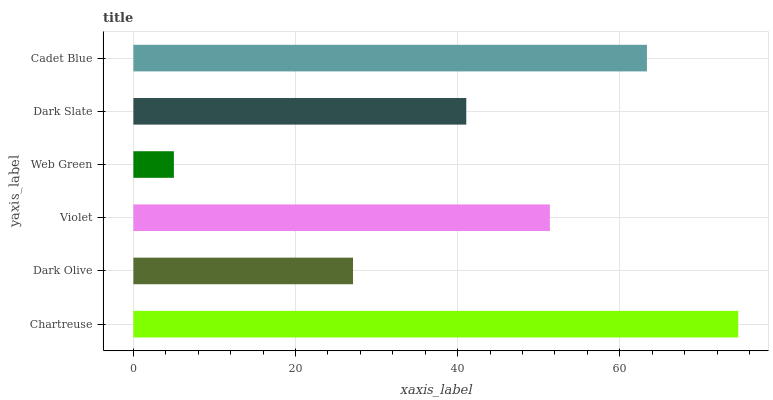Is Web Green the minimum?
Answer yes or no. Yes. Is Chartreuse the maximum?
Answer yes or no. Yes. Is Dark Olive the minimum?
Answer yes or no. No. Is Dark Olive the maximum?
Answer yes or no. No. Is Chartreuse greater than Dark Olive?
Answer yes or no. Yes. Is Dark Olive less than Chartreuse?
Answer yes or no. Yes. Is Dark Olive greater than Chartreuse?
Answer yes or no. No. Is Chartreuse less than Dark Olive?
Answer yes or no. No. Is Violet the high median?
Answer yes or no. Yes. Is Dark Slate the low median?
Answer yes or no. Yes. Is Web Green the high median?
Answer yes or no. No. Is Cadet Blue the low median?
Answer yes or no. No. 